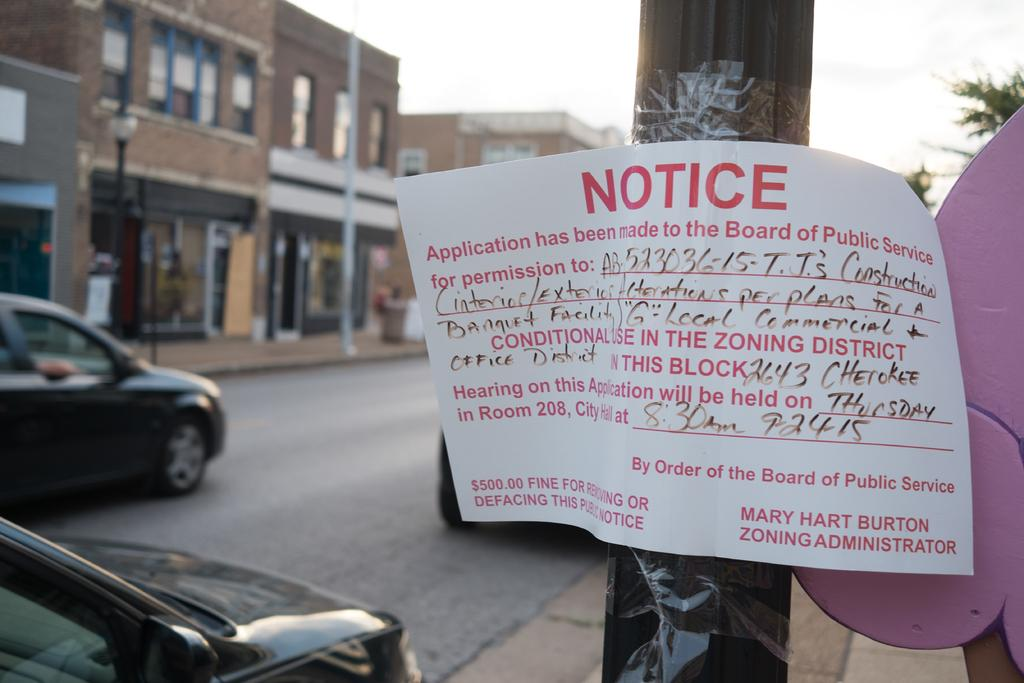What is located on the right side of the image? There is a notice paper on the right side of the image. How is the notice attached in the image? The notice is attached to a paper. What can be seen on the left side of the image? Cars are moving on the left side of the image. Where are the cars located in the image? The cars are on a road. What type of structures are visible in the image? There are buildings visible in the image. What type of fowl can be seen flying over the buildings in the image? There is no fowl visible in the image; it only shows a notice paper, cars on a road, and buildings. 